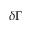<formula> <loc_0><loc_0><loc_500><loc_500>\delta \Gamma</formula> 